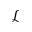<formula> <loc_0><loc_0><loc_500><loc_500>\mathcal { L }</formula> 